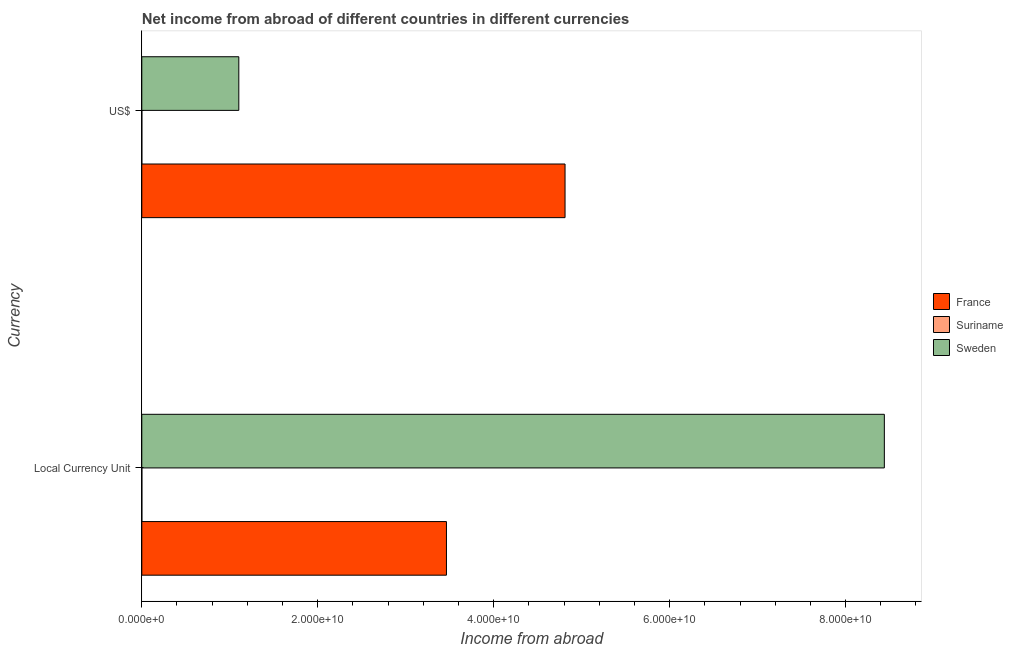How many bars are there on the 1st tick from the top?
Ensure brevity in your answer.  3. How many bars are there on the 1st tick from the bottom?
Your answer should be compact. 3. What is the label of the 2nd group of bars from the top?
Give a very brief answer. Local Currency Unit. What is the income from abroad in us$ in Sweden?
Your answer should be compact. 1.10e+1. Across all countries, what is the maximum income from abroad in constant 2005 us$?
Make the answer very short. 8.44e+1. Across all countries, what is the minimum income from abroad in constant 2005 us$?
Offer a very short reply. 4.80e+06. In which country was the income from abroad in us$ maximum?
Ensure brevity in your answer.  France. In which country was the income from abroad in us$ minimum?
Offer a very short reply. Suriname. What is the total income from abroad in us$ in the graph?
Your answer should be compact. 5.91e+1. What is the difference between the income from abroad in constant 2005 us$ in Suriname and that in France?
Provide a succinct answer. -3.46e+1. What is the difference between the income from abroad in constant 2005 us$ in Sweden and the income from abroad in us$ in France?
Provide a succinct answer. 3.63e+1. What is the average income from abroad in us$ per country?
Provide a succinct answer. 1.97e+1. What is the difference between the income from abroad in us$ and income from abroad in constant 2005 us$ in Sweden?
Your response must be concise. -7.34e+1. What is the ratio of the income from abroad in constant 2005 us$ in France to that in Suriname?
Give a very brief answer. 7214.58. Is the income from abroad in us$ in Suriname less than that in France?
Your answer should be compact. Yes. What does the 2nd bar from the top in US$ represents?
Your answer should be compact. Suriname. What does the 1st bar from the bottom in US$ represents?
Your response must be concise. France. Are all the bars in the graph horizontal?
Your answer should be very brief. Yes. How many countries are there in the graph?
Offer a very short reply. 3. Are the values on the major ticks of X-axis written in scientific E-notation?
Your answer should be very brief. Yes. Does the graph contain grids?
Offer a very short reply. No. Where does the legend appear in the graph?
Ensure brevity in your answer.  Center right. How many legend labels are there?
Give a very brief answer. 3. What is the title of the graph?
Your answer should be very brief. Net income from abroad of different countries in different currencies. Does "Angola" appear as one of the legend labels in the graph?
Make the answer very short. No. What is the label or title of the X-axis?
Provide a succinct answer. Income from abroad. What is the label or title of the Y-axis?
Provide a short and direct response. Currency. What is the Income from abroad of France in Local Currency Unit?
Make the answer very short. 3.46e+1. What is the Income from abroad of Suriname in Local Currency Unit?
Provide a short and direct response. 4.80e+06. What is the Income from abroad of Sweden in Local Currency Unit?
Provide a succinct answer. 8.44e+1. What is the Income from abroad of France in US$?
Your answer should be very brief. 4.81e+1. What is the Income from abroad in Suriname in US$?
Keep it short and to the point. 1.75e+06. What is the Income from abroad in Sweden in US$?
Provide a short and direct response. 1.10e+1. Across all Currency, what is the maximum Income from abroad in France?
Provide a short and direct response. 4.81e+1. Across all Currency, what is the maximum Income from abroad of Suriname?
Ensure brevity in your answer.  4.80e+06. Across all Currency, what is the maximum Income from abroad of Sweden?
Your answer should be very brief. 8.44e+1. Across all Currency, what is the minimum Income from abroad of France?
Offer a terse response. 3.46e+1. Across all Currency, what is the minimum Income from abroad in Suriname?
Provide a short and direct response. 1.75e+06. Across all Currency, what is the minimum Income from abroad in Sweden?
Keep it short and to the point. 1.10e+1. What is the total Income from abroad in France in the graph?
Your answer should be compact. 8.27e+1. What is the total Income from abroad in Suriname in the graph?
Offer a very short reply. 6.55e+06. What is the total Income from abroad of Sweden in the graph?
Ensure brevity in your answer.  9.54e+1. What is the difference between the Income from abroad of France in Local Currency Unit and that in US$?
Your answer should be compact. -1.35e+1. What is the difference between the Income from abroad in Suriname in Local Currency Unit and that in US$?
Keep it short and to the point. 3.05e+06. What is the difference between the Income from abroad of Sweden in Local Currency Unit and that in US$?
Ensure brevity in your answer.  7.34e+1. What is the difference between the Income from abroad in France in Local Currency Unit and the Income from abroad in Suriname in US$?
Provide a succinct answer. 3.46e+1. What is the difference between the Income from abroad of France in Local Currency Unit and the Income from abroad of Sweden in US$?
Provide a short and direct response. 2.36e+1. What is the difference between the Income from abroad of Suriname in Local Currency Unit and the Income from abroad of Sweden in US$?
Offer a terse response. -1.10e+1. What is the average Income from abroad in France per Currency?
Your answer should be compact. 4.14e+1. What is the average Income from abroad of Suriname per Currency?
Offer a very short reply. 3.27e+06. What is the average Income from abroad in Sweden per Currency?
Make the answer very short. 4.77e+1. What is the difference between the Income from abroad of France and Income from abroad of Suriname in Local Currency Unit?
Offer a very short reply. 3.46e+1. What is the difference between the Income from abroad of France and Income from abroad of Sweden in Local Currency Unit?
Keep it short and to the point. -4.98e+1. What is the difference between the Income from abroad in Suriname and Income from abroad in Sweden in Local Currency Unit?
Your answer should be compact. -8.44e+1. What is the difference between the Income from abroad of France and Income from abroad of Suriname in US$?
Offer a very short reply. 4.81e+1. What is the difference between the Income from abroad of France and Income from abroad of Sweden in US$?
Make the answer very short. 3.71e+1. What is the difference between the Income from abroad of Suriname and Income from abroad of Sweden in US$?
Offer a terse response. -1.10e+1. What is the ratio of the Income from abroad in France in Local Currency Unit to that in US$?
Your answer should be compact. 0.72. What is the ratio of the Income from abroad in Suriname in Local Currency Unit to that in US$?
Your response must be concise. 2.75. What is the ratio of the Income from abroad of Sweden in Local Currency Unit to that in US$?
Provide a succinct answer. 7.65. What is the difference between the highest and the second highest Income from abroad in France?
Offer a very short reply. 1.35e+1. What is the difference between the highest and the second highest Income from abroad of Suriname?
Your answer should be very brief. 3.05e+06. What is the difference between the highest and the second highest Income from abroad in Sweden?
Offer a very short reply. 7.34e+1. What is the difference between the highest and the lowest Income from abroad in France?
Ensure brevity in your answer.  1.35e+1. What is the difference between the highest and the lowest Income from abroad in Suriname?
Make the answer very short. 3.05e+06. What is the difference between the highest and the lowest Income from abroad in Sweden?
Ensure brevity in your answer.  7.34e+1. 